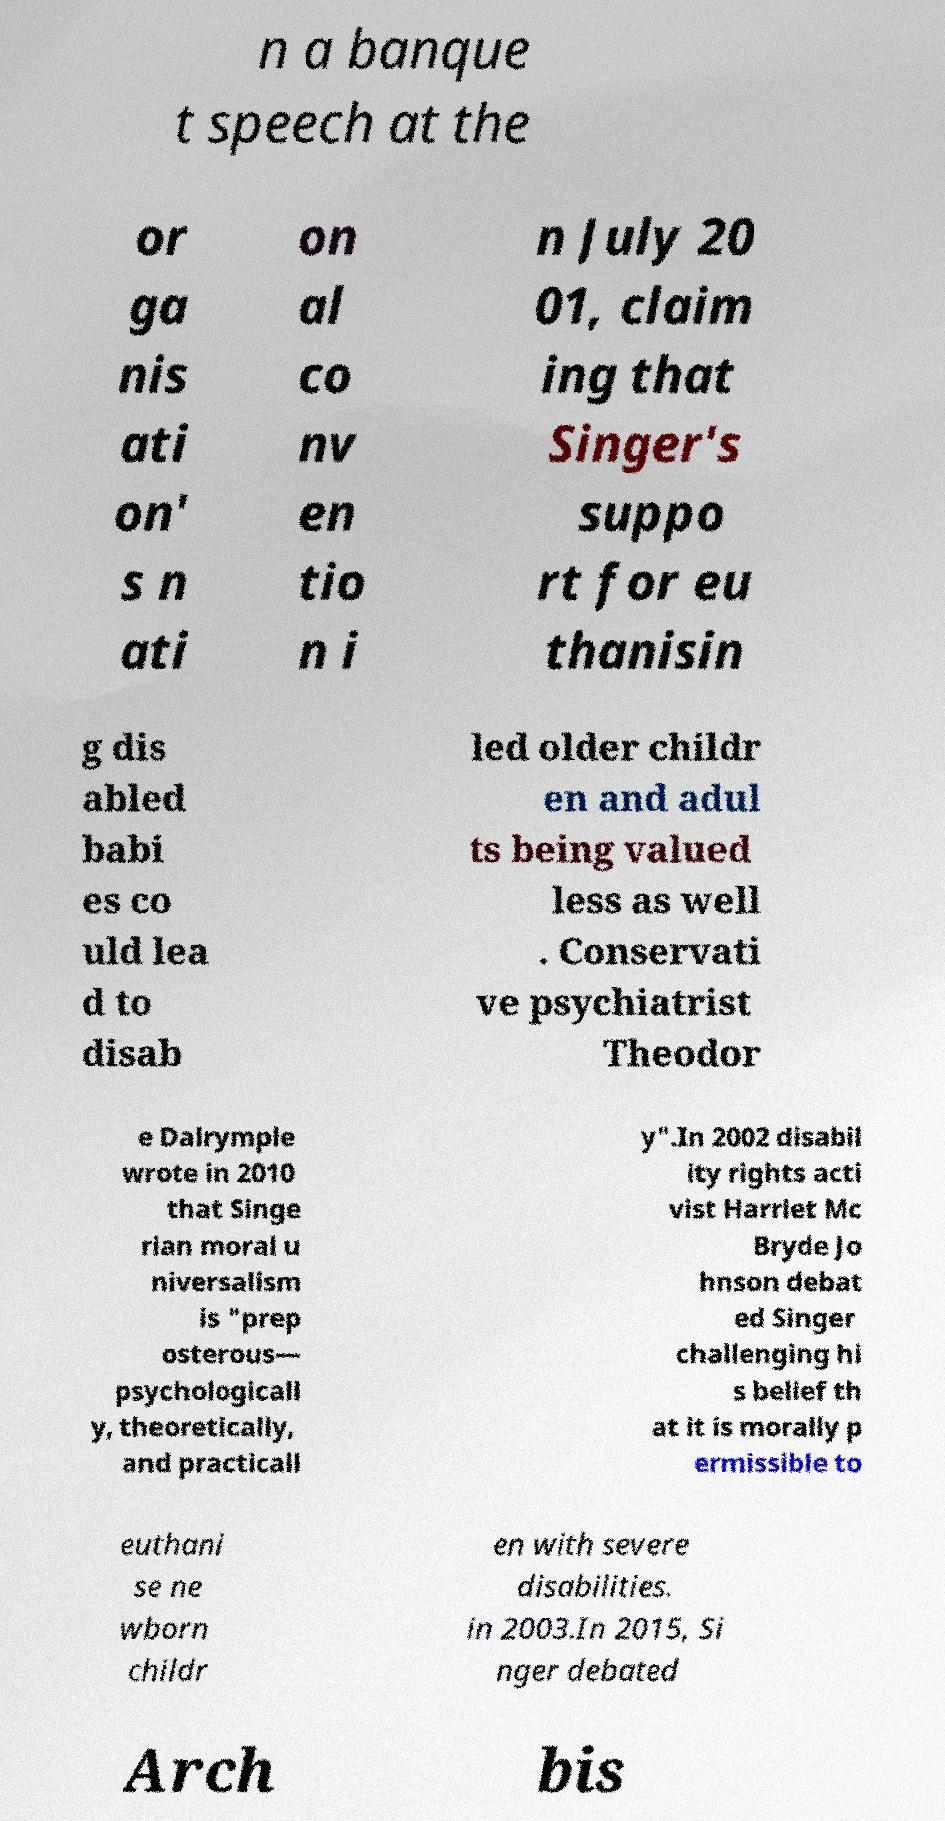I need the written content from this picture converted into text. Can you do that? n a banque t speech at the or ga nis ati on' s n ati on al co nv en tio n i n July 20 01, claim ing that Singer's suppo rt for eu thanisin g dis abled babi es co uld lea d to disab led older childr en and adul ts being valued less as well . Conservati ve psychiatrist Theodor e Dalrymple wrote in 2010 that Singe rian moral u niversalism is "prep osterous— psychologicall y, theoretically, and practicall y".In 2002 disabil ity rights acti vist Harriet Mc Bryde Jo hnson debat ed Singer challenging hi s belief th at it is morally p ermissible to euthani se ne wborn childr en with severe disabilities. in 2003.In 2015, Si nger debated Arch bis 